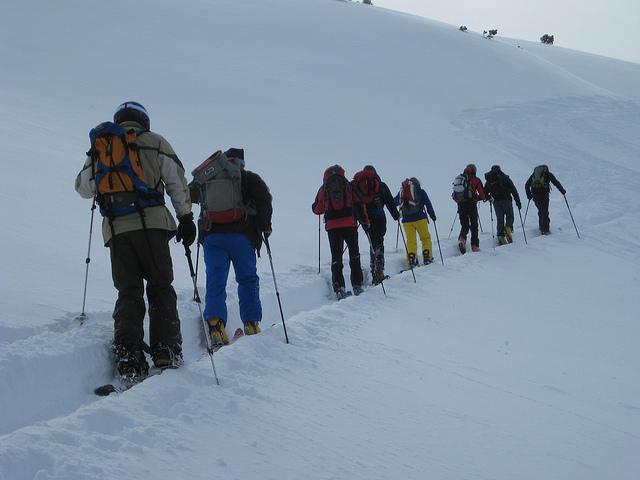What direction does the trail take just ahead?
Concise answer only. Left. Are then men looking to the right?
Concise answer only. No. Do their outfits match?
Answer briefly. No. Does everyone have a bag?
Answer briefly. Yes. Are there any people visible in this picture, apart from the main group?
Write a very short answer. No. Are these people traveling together?
Write a very short answer. Yes. 